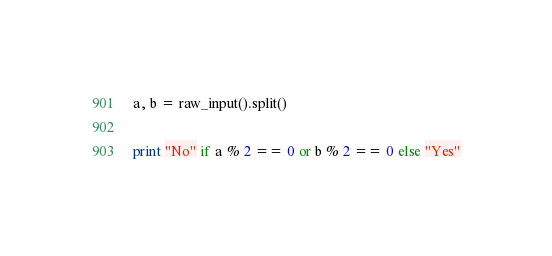Convert code to text. <code><loc_0><loc_0><loc_500><loc_500><_Python_>a, b = raw_input().split()

print "No" if a % 2 == 0 or b % 2 == 0 else "Yes"</code> 